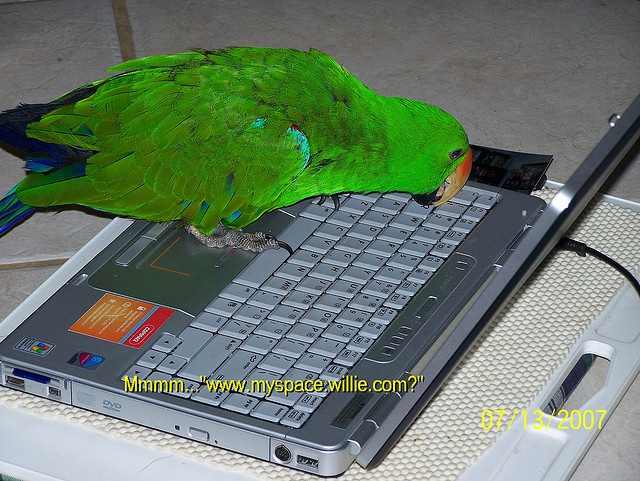Describe the objects in this image and their specific colors. I can see laptop in gray, darkgray, and black tones and bird in gray, darkgreen, green, and black tones in this image. 